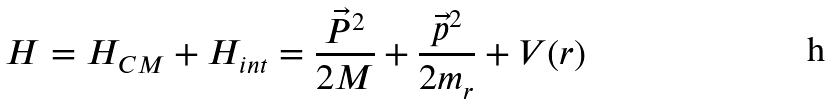<formula> <loc_0><loc_0><loc_500><loc_500>H = H _ { C M } + H _ { i n t } = \frac { \vec { P } ^ { 2 } } { 2 M } + \frac { \vec { p } ^ { 2 } } { 2 m _ { r } } + V ( r )</formula> 